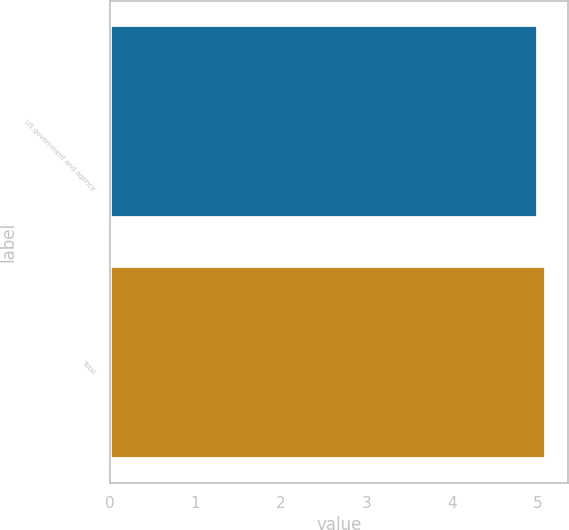Convert chart to OTSL. <chart><loc_0><loc_0><loc_500><loc_500><bar_chart><fcel>US government and agency<fcel>Total<nl><fcel>5<fcel>5.1<nl></chart> 